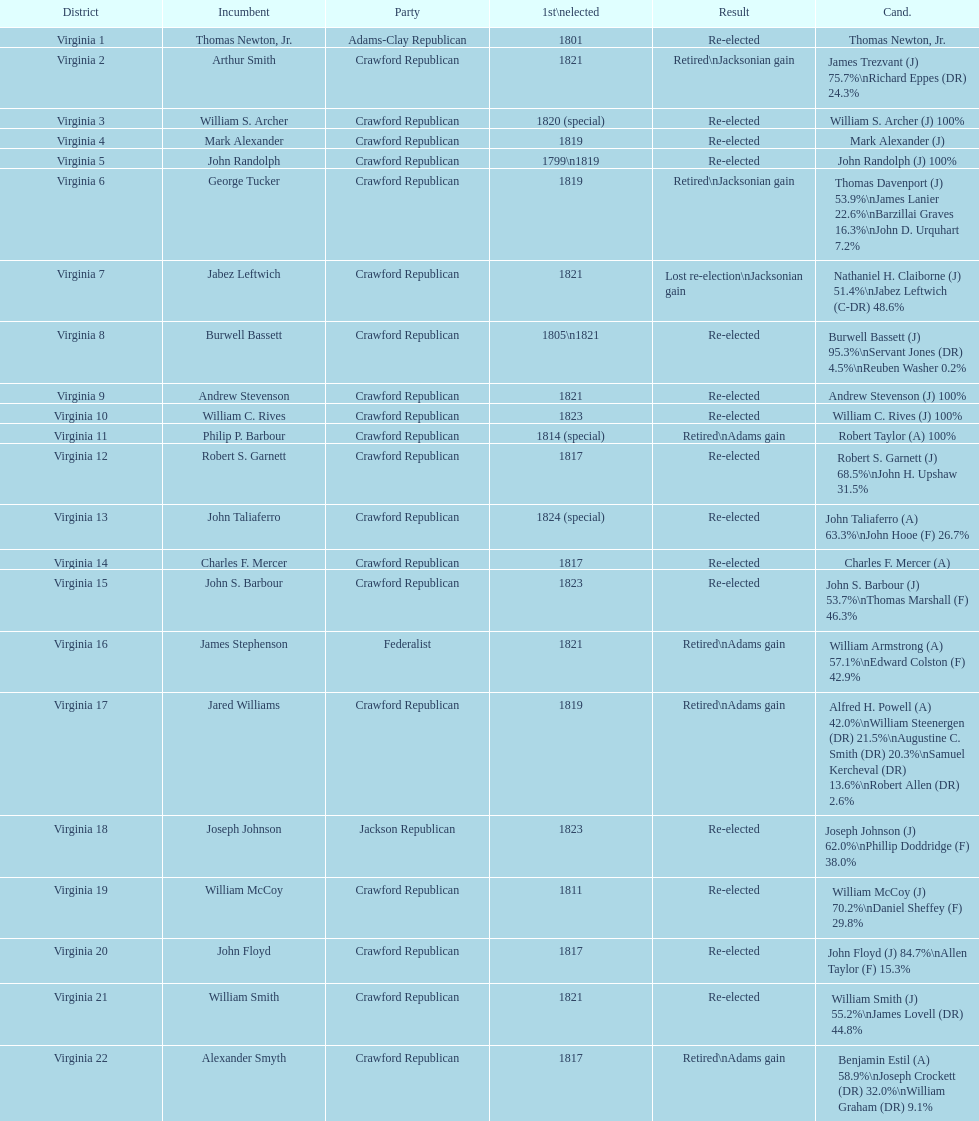How many districts are there in virginia? 22. 